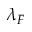<formula> <loc_0><loc_0><loc_500><loc_500>\lambda _ { F }</formula> 